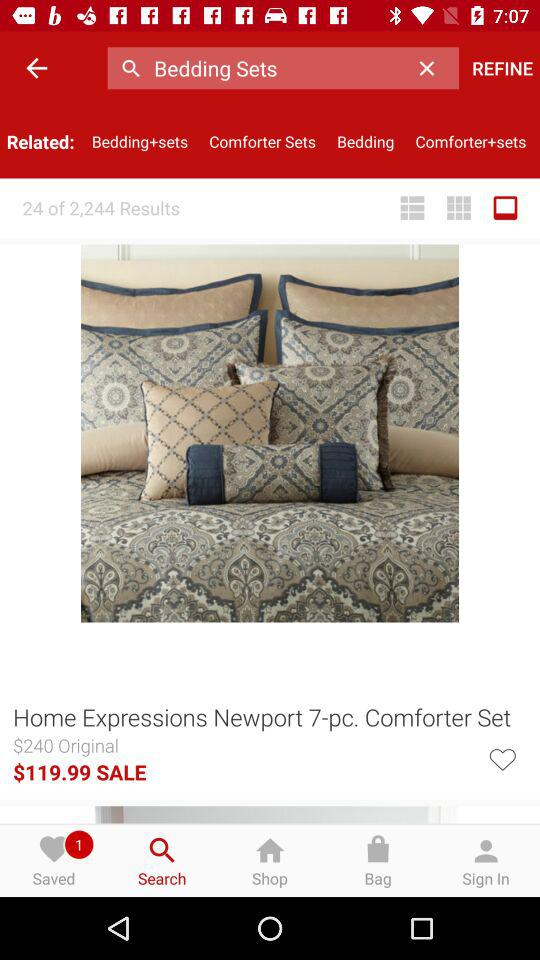How many items are saved? There is one saved item. 